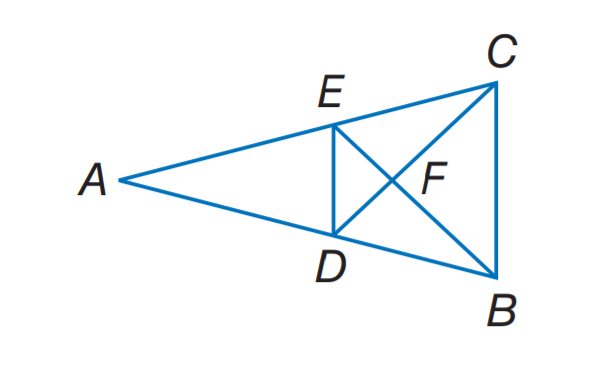Question: Find the perimeter of the \triangle D E F, if \triangle D E F \sim \triangle C B F, perimeter of \triangle C B F = 27, D F = 6, F C = 8.
Choices:
A. 16
B. 17.25
C. 20.25
D. 27
Answer with the letter. Answer: C 